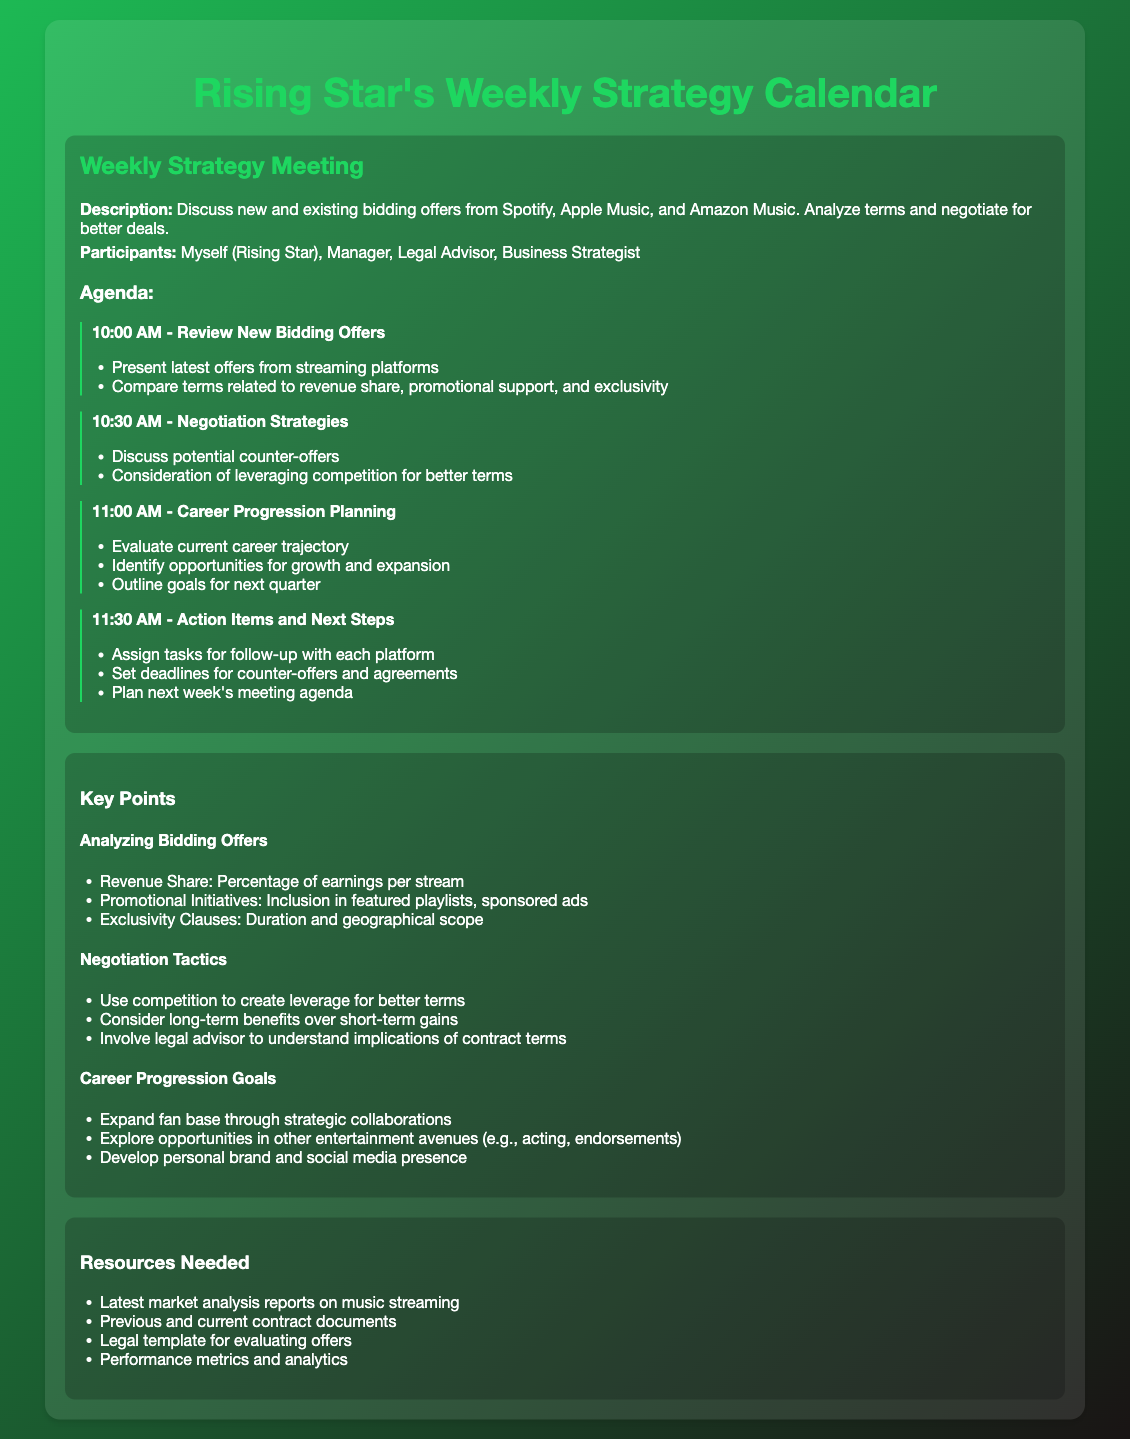What time does the meeting start? The meeting starts at 10:00 AM.
Answer: 10:00 AM Who are the participants in the meeting? The participants include Myself (Rising Star), Manager, Legal Advisor, and Business Strategist.
Answer: Myself (Rising Star), Manager, Legal Advisor, Business Strategist What is one of the agenda items for the meeting? One of the agenda items is "Review New Bidding Offers" discussed at 10:00 AM.
Answer: Review New Bidding Offers What is a key point regarding negotiation tactics? A key point is to use competition to create leverage for better terms.
Answer: Use competition to create leverage How many agenda items are listed in the document? There are four agenda items listed in the document.
Answer: Four What is outlined during the "Career Progression Planning" segment? The segment evaluates current career trajectory and identifies opportunities for growth.
Answer: Evaluate current career trajectory What are the resources needed for the meeting? One of the resources needed is the latest market analysis reports on music streaming.
Answer: Latest market analysis reports What is a specific negotiation strategy mentioned? Consideration of long-term benefits over short-term gains is mentioned.
Answer: Consider long-term benefits At what time is "Action Items and Next Steps" scheduled? "Action Items and Next Steps" is scheduled for 11:30 AM.
Answer: 11:30 AM 